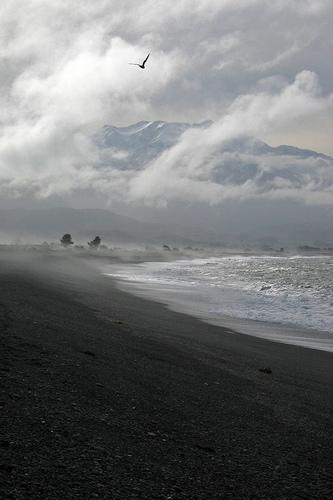What is in the sky?
Keep it brief. Bird. Is it a cloudy day?
Give a very brief answer. Yes. Is it a clear day?
Short answer required. No. Is the water in motion?
Keep it brief. Yes. What is shown in the sky?
Short answer required. Bird. Are there any clouds in the sky?
Answer briefly. Yes. Is it clear and sunny?
Be succinct. No. What body of water is in the picture?
Short answer required. Ocean. What can be seen in the background?
Be succinct. Clouds. Is there anybody on the body?
Answer briefly. No. 